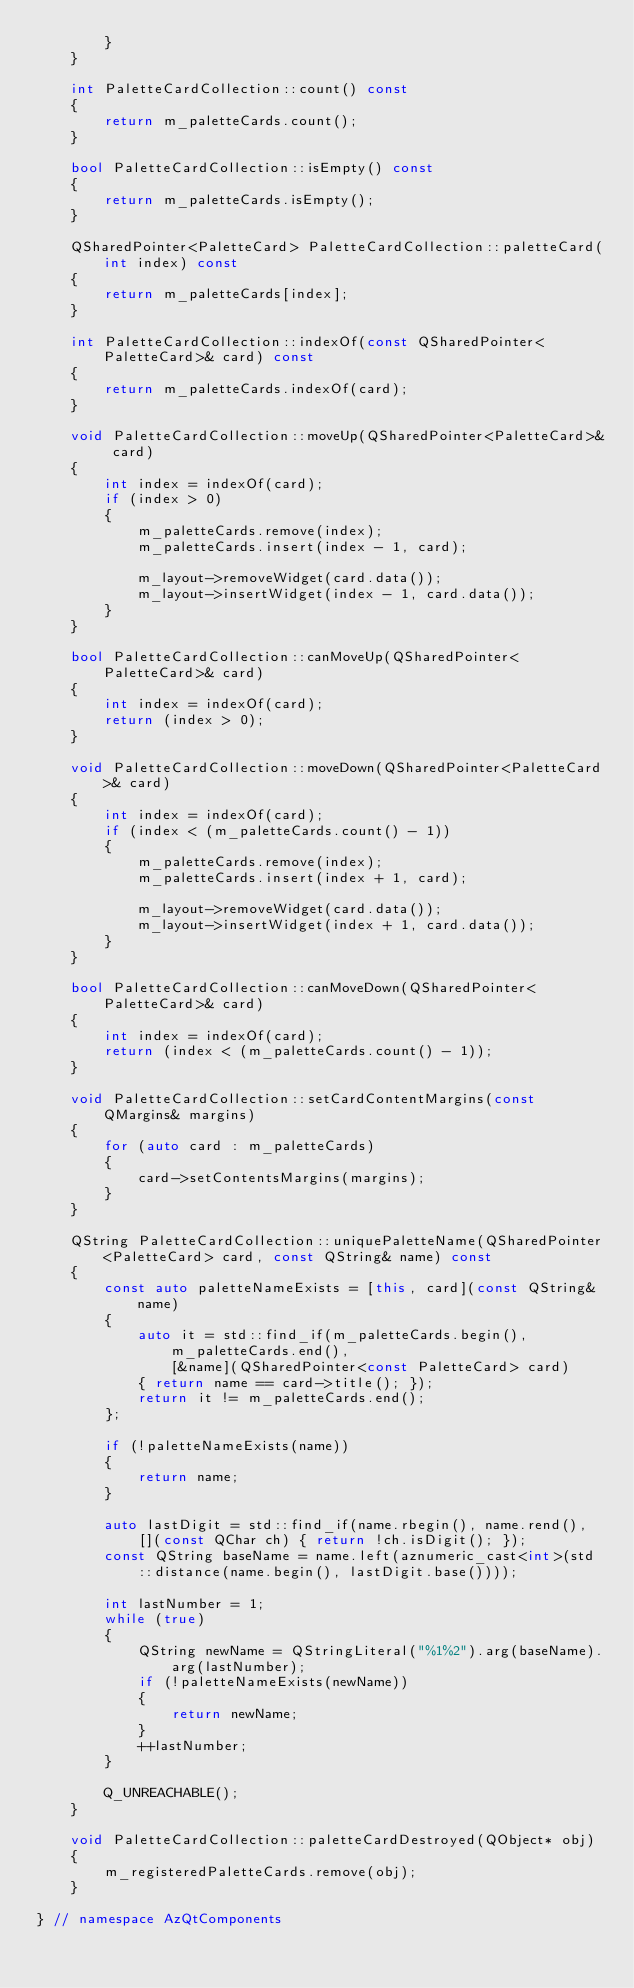<code> <loc_0><loc_0><loc_500><loc_500><_C++_>        }
    }

    int PaletteCardCollection::count() const
    {
        return m_paletteCards.count();
    }

    bool PaletteCardCollection::isEmpty() const
    {
        return m_paletteCards.isEmpty();
    }

    QSharedPointer<PaletteCard> PaletteCardCollection::paletteCard(int index) const
    {
        return m_paletteCards[index];
    }

    int PaletteCardCollection::indexOf(const QSharedPointer<PaletteCard>& card) const
    {
        return m_paletteCards.indexOf(card);
    }

    void PaletteCardCollection::moveUp(QSharedPointer<PaletteCard>& card)
    {
        int index = indexOf(card);
        if (index > 0)
        {
            m_paletteCards.remove(index);
            m_paletteCards.insert(index - 1, card);

            m_layout->removeWidget(card.data());
            m_layout->insertWidget(index - 1, card.data());
        }
    }

    bool PaletteCardCollection::canMoveUp(QSharedPointer<PaletteCard>& card)
    {
        int index = indexOf(card);
        return (index > 0);
    }

    void PaletteCardCollection::moveDown(QSharedPointer<PaletteCard>& card)
    {
        int index = indexOf(card);
        if (index < (m_paletteCards.count() - 1))
        {
            m_paletteCards.remove(index);
            m_paletteCards.insert(index + 1, card);

            m_layout->removeWidget(card.data());
            m_layout->insertWidget(index + 1, card.data());
        }
    }

    bool PaletteCardCollection::canMoveDown(QSharedPointer<PaletteCard>& card)
    {
        int index = indexOf(card);
        return (index < (m_paletteCards.count() - 1));
    }

    void PaletteCardCollection::setCardContentMargins(const QMargins& margins)
    {
        for (auto card : m_paletteCards)
        {
            card->setContentsMargins(margins);
        }
    }

    QString PaletteCardCollection::uniquePaletteName(QSharedPointer<PaletteCard> card, const QString& name) const
    {
        const auto paletteNameExists = [this, card](const QString& name)
        {
            auto it = std::find_if(m_paletteCards.begin(), m_paletteCards.end(),
                [&name](QSharedPointer<const PaletteCard> card)
            { return name == card->title(); });
            return it != m_paletteCards.end();
        };

        if (!paletteNameExists(name))
        {
            return name;
        }

        auto lastDigit = std::find_if(name.rbegin(), name.rend(),
            [](const QChar ch) { return !ch.isDigit(); });
        const QString baseName = name.left(aznumeric_cast<int>(std::distance(name.begin(), lastDigit.base())));

        int lastNumber = 1;
        while (true)
        {
            QString newName = QStringLiteral("%1%2").arg(baseName).arg(lastNumber);
            if (!paletteNameExists(newName))
            {
                return newName;
            }
            ++lastNumber;
        }

        Q_UNREACHABLE();
    }

    void PaletteCardCollection::paletteCardDestroyed(QObject* obj)
    {
        m_registeredPaletteCards.remove(obj);
    }

} // namespace AzQtComponents</code> 